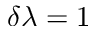Convert formula to latex. <formula><loc_0><loc_0><loc_500><loc_500>\delta \lambda = 1</formula> 